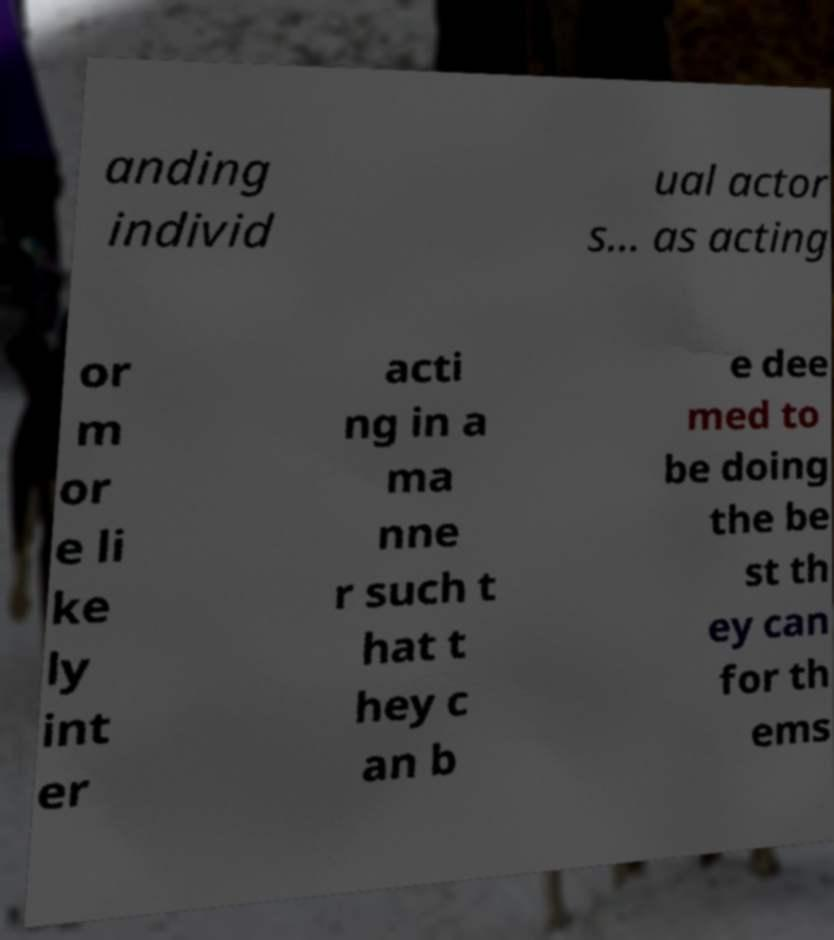What messages or text are displayed in this image? I need them in a readable, typed format. anding individ ual actor s... as acting or m or e li ke ly int er acti ng in a ma nne r such t hat t hey c an b e dee med to be doing the be st th ey can for th ems 